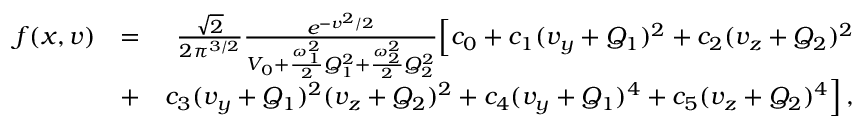<formula> <loc_0><loc_0><loc_500><loc_500>\begin{array} { r l r } { f ( x , v ) } & { = } & { \frac { \sqrt { 2 } } { 2 \pi ^ { 3 / 2 } } \frac { e ^ { - v ^ { 2 } / 2 } } { V _ { 0 } + \frac { \omega _ { 1 } ^ { 2 } } { 2 } Q _ { 1 } ^ { 2 } + \frac { \omega _ { 2 } ^ { 2 } } { 2 } Q _ { 2 } ^ { 2 } } \left [ c _ { 0 } + c _ { 1 } ( v _ { y } + Q _ { 1 } ) ^ { 2 } + c _ { 2 } ( v _ { z } + Q _ { 2 } ) ^ { 2 } } \\ & { + } & { c _ { 3 } ( v _ { y } + Q _ { 1 } ) ^ { 2 } ( v _ { z } + Q _ { 2 } ) ^ { 2 } + c _ { 4 } ( v _ { y } + Q _ { 1 } ) ^ { 4 } + c _ { 5 } ( v _ { z } + Q _ { 2 } ) ^ { 4 } \right ] \, , } \end{array}</formula> 